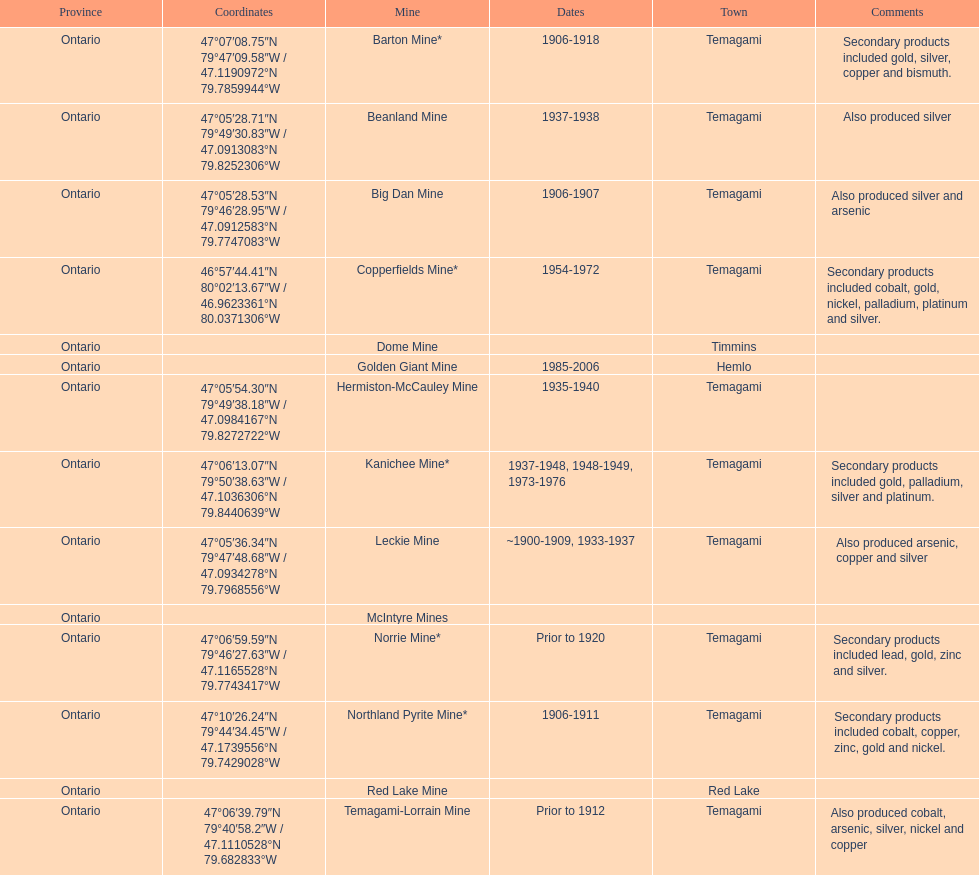How many instances is temagami mentioned on the list? 10. 